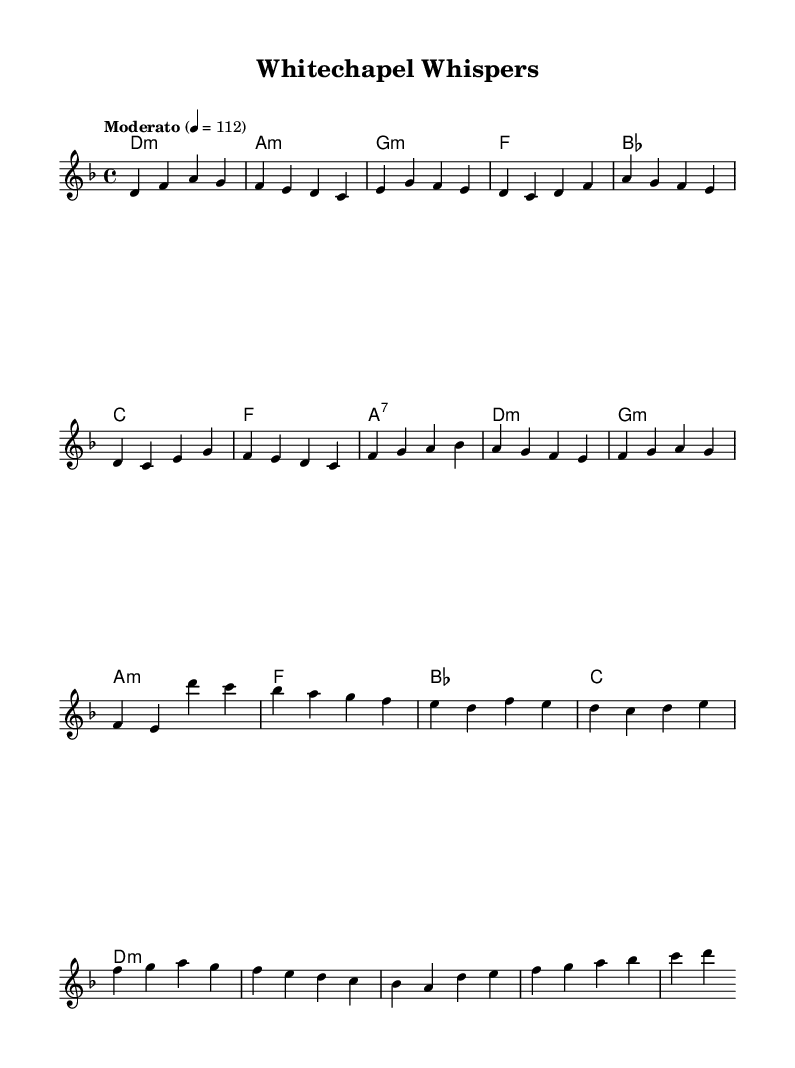What is the key signature of this music? The key signature is D minor, which typically has one flat (B flat) and focuses on the tonality of D minor throughout the piece.
Answer: D minor What is the time signature of this music? The time signature is 4/4, indicated at the beginning of the score, which means there are four beats in each measure.
Answer: 4/4 What is the tempo marking indicated in the sheet music? The tempo marking indicates "Moderato" with a metronome mark of 112, suggesting a moderate pace for the performance of this piece.
Answer: Moderato 4 = 112 How many measures are there in the chorus section? By counting the measures in the written score for the chorus (which is marked and follows the pre-chorus), we find there are eight measures total.
Answer: 8 Which chord appears immediately before the pre-chorus? The chord that appears right before the pre-chorus is F major, as it is the last chord in the verse section leading into the pre-chorus.
Answer: F What is the last chord of the song? The last chord in the score is D minor, which represents the chord that concludes the musical piece and returns to the home key of the song.
Answer: D minor 